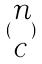<formula> <loc_0><loc_0><loc_500><loc_500>( \begin{matrix} n \\ c \end{matrix} )</formula> 